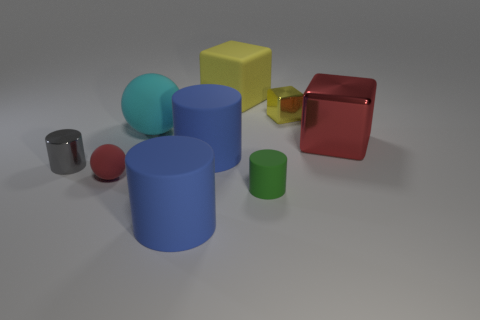Can you describe the lighting in the scene? The lighting in the image appears to be soft and diffused, coming from an angle that creates gentle shadows to the right of the objects. This suggests an overhead light source that's possibly large or filtered to avoid harsh highlights on the objects, giving the scene an evenly lit, soft-box photographic studio feel. 